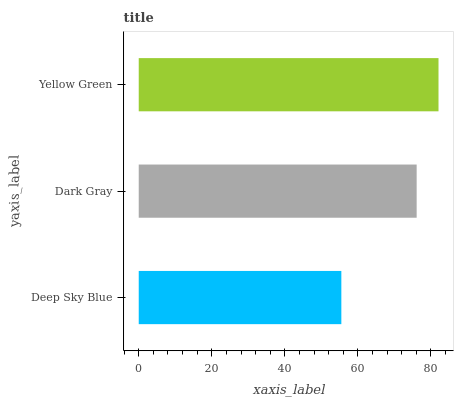Is Deep Sky Blue the minimum?
Answer yes or no. Yes. Is Yellow Green the maximum?
Answer yes or no. Yes. Is Dark Gray the minimum?
Answer yes or no. No. Is Dark Gray the maximum?
Answer yes or no. No. Is Dark Gray greater than Deep Sky Blue?
Answer yes or no. Yes. Is Deep Sky Blue less than Dark Gray?
Answer yes or no. Yes. Is Deep Sky Blue greater than Dark Gray?
Answer yes or no. No. Is Dark Gray less than Deep Sky Blue?
Answer yes or no. No. Is Dark Gray the high median?
Answer yes or no. Yes. Is Dark Gray the low median?
Answer yes or no. Yes. Is Yellow Green the high median?
Answer yes or no. No. Is Deep Sky Blue the low median?
Answer yes or no. No. 